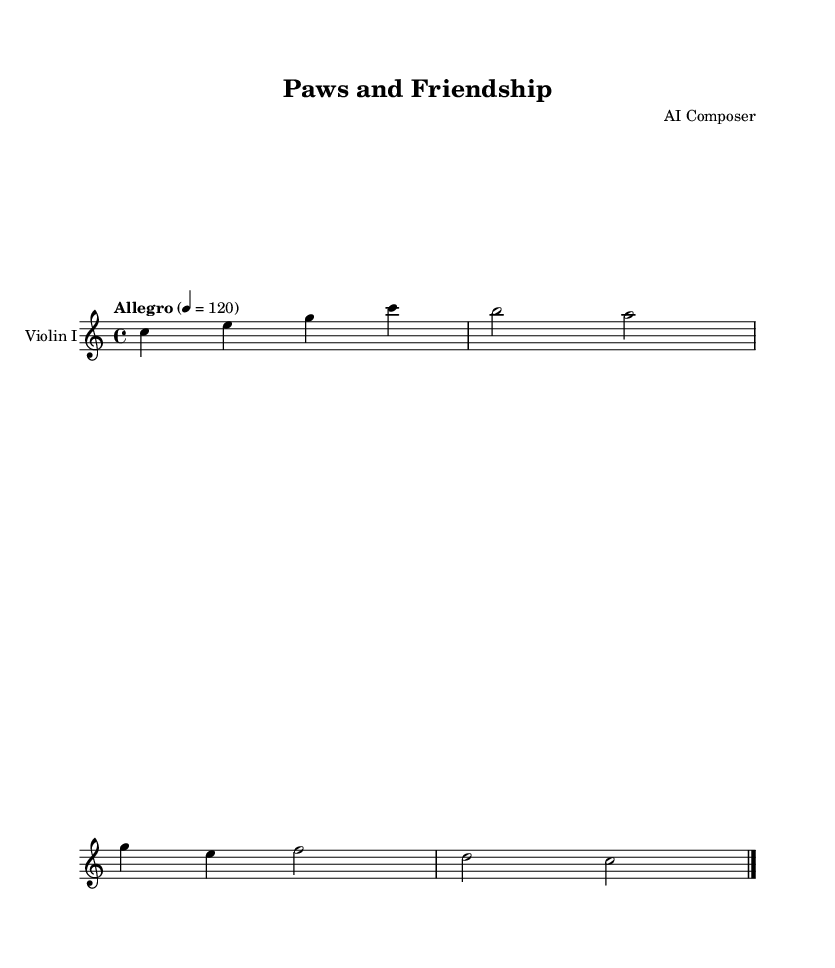What is the key signature of this music? The key signature, indicated at the beginning of the staff, shows that there are no sharps or flats, which corresponds to the key of C major.
Answer: C major What is the time signature of this music? The time signature is located at the beginning of the music, showing a numerator of 4 and a denominator of 4, which indicates that there are four beats per measure.
Answer: 4/4 What is the tempo marking of this piece? The tempo marking appears at the beginning and is specified as "Allegro" with a metronome marking of 120, indicating a fast and lively pace for the piece.
Answer: Allegro How many measures are in this excerpt? By counting the bar lines indicated in the sheet music, we can see there are two complete measures followed by a final bar line. Thus, there are a total of 2 measures in this excerpt.
Answer: 2 What instrument is this piece written for? The instrument name at the top of the staff clearly states that this music is written for "Violin I", indicating that it is specifically arranged for the first violin.
Answer: Violin I What is the dynamic level implied in this score? There are no dynamic markings given in this excerpt, but based on the lively tempo and the nature of the composition, it is reasonable to assume that it should be performed at a moderate to slightly loud dynamic level, generally indicated by "mf" or "f".
Answer: N/A 